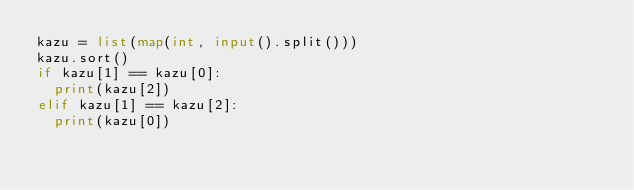<code> <loc_0><loc_0><loc_500><loc_500><_Python_>kazu = list(map(int, input().split()))
kazu.sort()
if kazu[1] == kazu[0]:
  print(kazu[2])
elif kazu[1] == kazu[2]:
  print(kazu[0])
</code> 